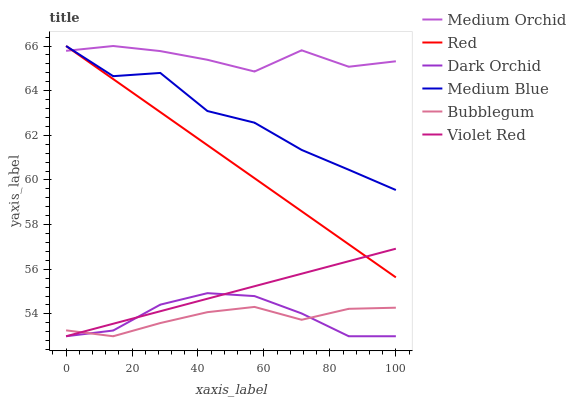Does Bubblegum have the minimum area under the curve?
Answer yes or no. Yes. Does Medium Orchid have the maximum area under the curve?
Answer yes or no. Yes. Does Medium Blue have the minimum area under the curve?
Answer yes or no. No. Does Medium Blue have the maximum area under the curve?
Answer yes or no. No. Is Red the smoothest?
Answer yes or no. Yes. Is Medium Blue the roughest?
Answer yes or no. Yes. Is Medium Orchid the smoothest?
Answer yes or no. No. Is Medium Orchid the roughest?
Answer yes or no. No. Does Violet Red have the lowest value?
Answer yes or no. Yes. Does Medium Blue have the lowest value?
Answer yes or no. No. Does Red have the highest value?
Answer yes or no. Yes. Does Bubblegum have the highest value?
Answer yes or no. No. Is Dark Orchid less than Red?
Answer yes or no. Yes. Is Medium Blue greater than Dark Orchid?
Answer yes or no. Yes. Does Bubblegum intersect Dark Orchid?
Answer yes or no. Yes. Is Bubblegum less than Dark Orchid?
Answer yes or no. No. Is Bubblegum greater than Dark Orchid?
Answer yes or no. No. Does Dark Orchid intersect Red?
Answer yes or no. No. 